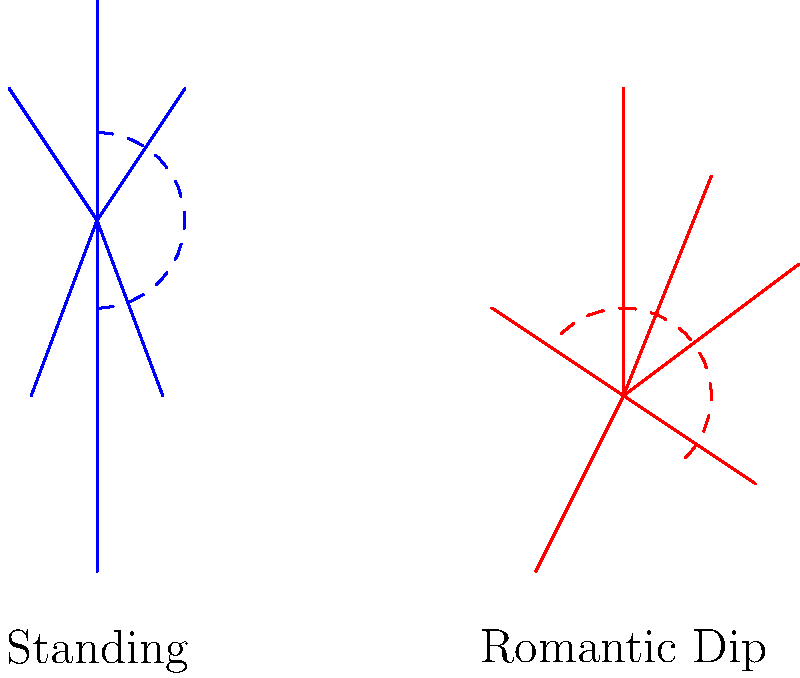In a romantic novel, the author describes a passionate scene where the hero sweeps the heroine into a dramatic dip. As an avid reader, you're curious about the biomechanics involved. How does the spinal curvature change when transitioning from a standing position to a romantic dip pose, and what implications might this have for the characters? To understand the spinal curvature changes, let's analyze the transition step-by-step:

1. Standing position:
   - The spine has a natural S-shaped curve with four main sections: cervical (neck), thoracic (upper back), lumbar (lower back), and sacral.
   - In the standing position, these curves are in their neutral alignment.

2. Romantic dip pose:
   - The lead partner leans backward, supporting the follower's weight.
   - The follower's upper body is tilted backward, supported by the lead.

3. Spinal curvature changes:
   - Cervical spine: Extends (bends backward) as the head tilts back.
   - Thoracic spine: Increases in extension (backward curve).
   - Lumbar spine: Significantly increases lordosis (inward curve).
   - Sacral spine: Tilts posteriorly (backward).

4. Overall effect:
   - The entire spine forms a more pronounced C-shape, with increased curvature compared to the standing position.

5. Implications for characters:
   - Increased muscular engagement: Core and back muscles work harder to maintain this position.
   - Potential for discomfort: Extended holds in this pose may cause strain, especially in the lower back.
   - Heightened sensation: The altered position may increase awareness of physical contact between partners.
   - Dramatic visual effect: The exaggerated curve creates a visually striking pose, often used to convey passion or surrender in romantic literature.

6. Biomechanical considerations:
   - The change in spinal curvature alters the body's center of gravity.
   - The lead partner must adjust their stance and strength to support this new distribution of weight.
   - The follower must trust their partner and relax into the pose while maintaining some core engagement for stability.

In romantic fiction, this pose symbolizes trust, passion, and dramatic flair, but from a biomechanical perspective, it represents a significant alteration in spinal alignment and muscular engagement.
Answer: Increased spinal curvature, forming a more pronounced C-shape with extended cervical and thoracic regions and increased lumbar lordosis. 